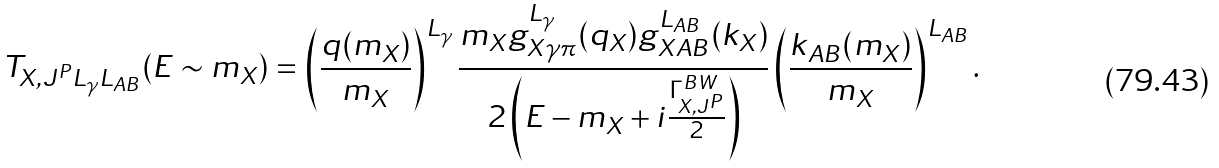Convert formula to latex. <formula><loc_0><loc_0><loc_500><loc_500>T _ { X , J ^ { P } L _ { \gamma } L _ { A B } } ( E \sim m _ { X } ) = \left ( { \frac { q ( m _ { X } ) } { m _ { X } } } \right ) ^ { L _ { \gamma } } { \frac { m _ { X } g _ { X \gamma \pi } ^ { L _ { \gamma } } ( q _ { X } ) g _ { X A B } ^ { L _ { A B } } ( k _ { X } ) } { 2 \left ( E - m _ { X } + i { \frac { \Gamma _ { X , J ^ { P } } ^ { B W } } { 2 } } \right ) } } \left ( { \frac { k _ { A B } ( m _ { X } ) } { m _ { X } } } \right ) ^ { L _ { A B } } .</formula> 